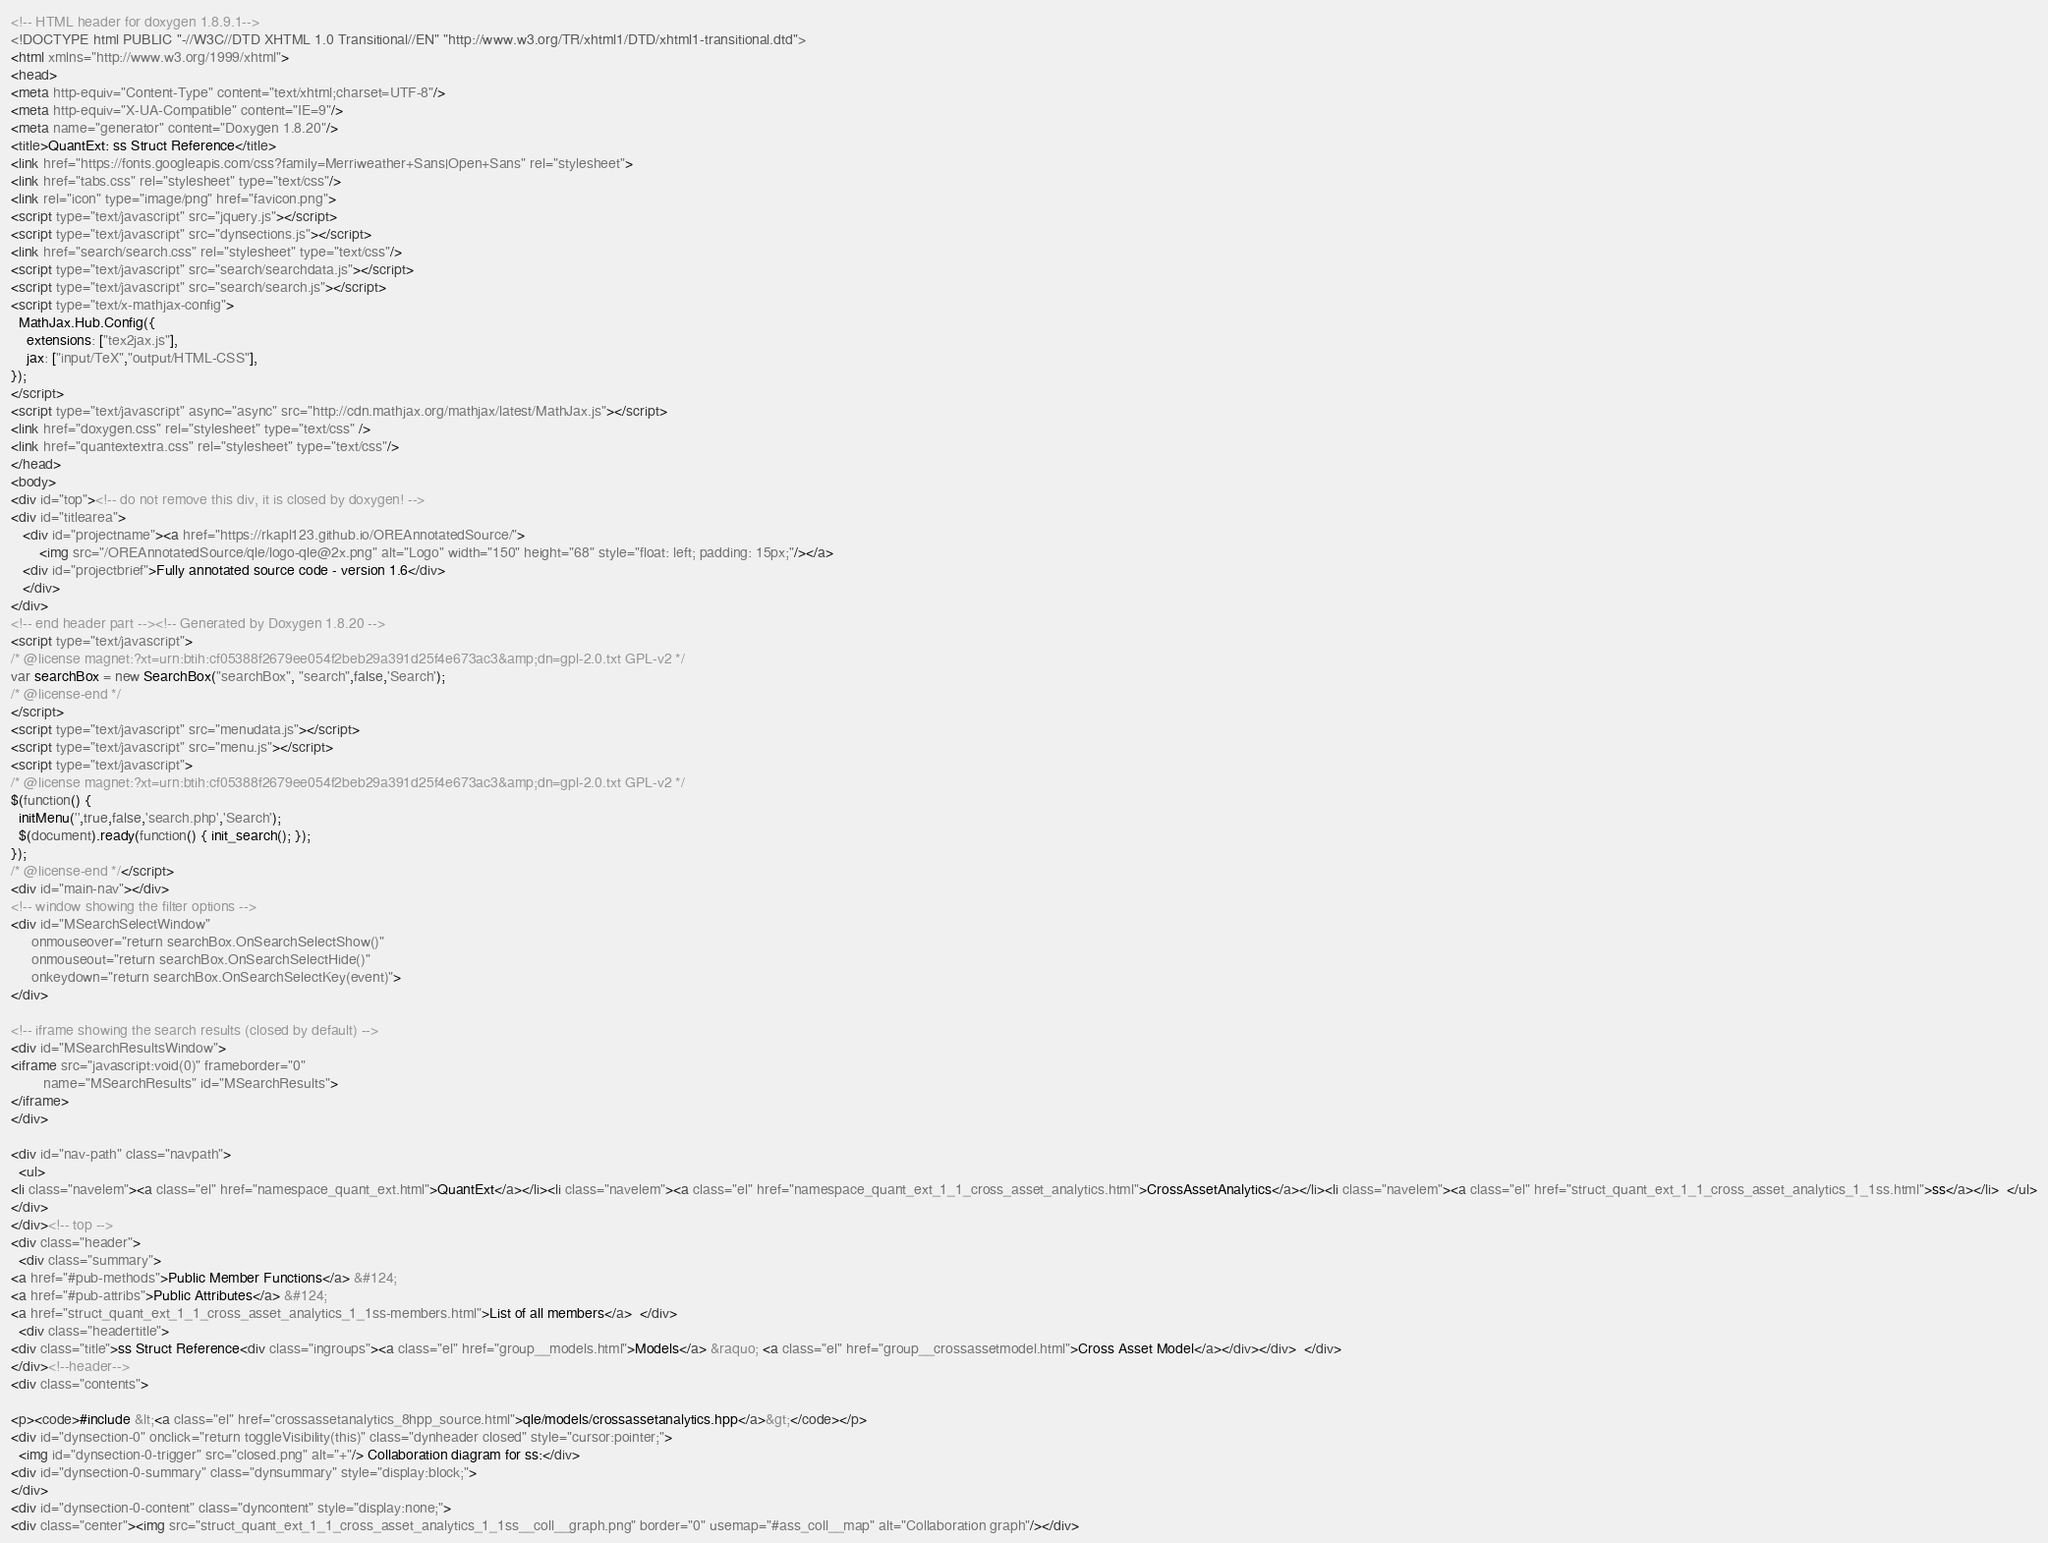<code> <loc_0><loc_0><loc_500><loc_500><_HTML_><!-- HTML header for doxygen 1.8.9.1-->
<!DOCTYPE html PUBLIC "-//W3C//DTD XHTML 1.0 Transitional//EN" "http://www.w3.org/TR/xhtml1/DTD/xhtml1-transitional.dtd">
<html xmlns="http://www.w3.org/1999/xhtml">
<head>
<meta http-equiv="Content-Type" content="text/xhtml;charset=UTF-8"/>
<meta http-equiv="X-UA-Compatible" content="IE=9"/>
<meta name="generator" content="Doxygen 1.8.20"/>
<title>QuantExt: ss Struct Reference</title>
<link href="https://fonts.googleapis.com/css?family=Merriweather+Sans|Open+Sans" rel="stylesheet">
<link href="tabs.css" rel="stylesheet" type="text/css"/>
<link rel="icon" type="image/png" href="favicon.png">
<script type="text/javascript" src="jquery.js"></script>
<script type="text/javascript" src="dynsections.js"></script>
<link href="search/search.css" rel="stylesheet" type="text/css"/>
<script type="text/javascript" src="search/searchdata.js"></script>
<script type="text/javascript" src="search/search.js"></script>
<script type="text/x-mathjax-config">
  MathJax.Hub.Config({
    extensions: ["tex2jax.js"],
    jax: ["input/TeX","output/HTML-CSS"],
});
</script>
<script type="text/javascript" async="async" src="http://cdn.mathjax.org/mathjax/latest/MathJax.js"></script>
<link href="doxygen.css" rel="stylesheet" type="text/css" />
<link href="quantextextra.css" rel="stylesheet" type="text/css"/>
</head>
<body>
<div id="top"><!-- do not remove this div, it is closed by doxygen! -->
<div id="titlearea">
   <div id="projectname"><a href="https://rkapl123.github.io/OREAnnotatedSource/">
       <img src="/OREAnnotatedSource/qle/logo-qle@2x.png" alt="Logo" width="150" height="68" style="float: left; padding: 15px;"/></a>
   <div id="projectbrief">Fully annotated source code - version 1.6</div>
   </div>
</div>
<!-- end header part --><!-- Generated by Doxygen 1.8.20 -->
<script type="text/javascript">
/* @license magnet:?xt=urn:btih:cf05388f2679ee054f2beb29a391d25f4e673ac3&amp;dn=gpl-2.0.txt GPL-v2 */
var searchBox = new SearchBox("searchBox", "search",false,'Search');
/* @license-end */
</script>
<script type="text/javascript" src="menudata.js"></script>
<script type="text/javascript" src="menu.js"></script>
<script type="text/javascript">
/* @license magnet:?xt=urn:btih:cf05388f2679ee054f2beb29a391d25f4e673ac3&amp;dn=gpl-2.0.txt GPL-v2 */
$(function() {
  initMenu('',true,false,'search.php','Search');
  $(document).ready(function() { init_search(); });
});
/* @license-end */</script>
<div id="main-nav"></div>
<!-- window showing the filter options -->
<div id="MSearchSelectWindow"
     onmouseover="return searchBox.OnSearchSelectShow()"
     onmouseout="return searchBox.OnSearchSelectHide()"
     onkeydown="return searchBox.OnSearchSelectKey(event)">
</div>

<!-- iframe showing the search results (closed by default) -->
<div id="MSearchResultsWindow">
<iframe src="javascript:void(0)" frameborder="0" 
        name="MSearchResults" id="MSearchResults">
</iframe>
</div>

<div id="nav-path" class="navpath">
  <ul>
<li class="navelem"><a class="el" href="namespace_quant_ext.html">QuantExt</a></li><li class="navelem"><a class="el" href="namespace_quant_ext_1_1_cross_asset_analytics.html">CrossAssetAnalytics</a></li><li class="navelem"><a class="el" href="struct_quant_ext_1_1_cross_asset_analytics_1_1ss.html">ss</a></li>  </ul>
</div>
</div><!-- top -->
<div class="header">
  <div class="summary">
<a href="#pub-methods">Public Member Functions</a> &#124;
<a href="#pub-attribs">Public Attributes</a> &#124;
<a href="struct_quant_ext_1_1_cross_asset_analytics_1_1ss-members.html">List of all members</a>  </div>
  <div class="headertitle">
<div class="title">ss Struct Reference<div class="ingroups"><a class="el" href="group__models.html">Models</a> &raquo; <a class="el" href="group__crossassetmodel.html">Cross Asset Model</a></div></div>  </div>
</div><!--header-->
<div class="contents">

<p><code>#include &lt;<a class="el" href="crossassetanalytics_8hpp_source.html">qle/models/crossassetanalytics.hpp</a>&gt;</code></p>
<div id="dynsection-0" onclick="return toggleVisibility(this)" class="dynheader closed" style="cursor:pointer;">
  <img id="dynsection-0-trigger" src="closed.png" alt="+"/> Collaboration diagram for ss:</div>
<div id="dynsection-0-summary" class="dynsummary" style="display:block;">
</div>
<div id="dynsection-0-content" class="dyncontent" style="display:none;">
<div class="center"><img src="struct_quant_ext_1_1_cross_asset_analytics_1_1ss__coll__graph.png" border="0" usemap="#ass_coll__map" alt="Collaboration graph"/></div></code> 